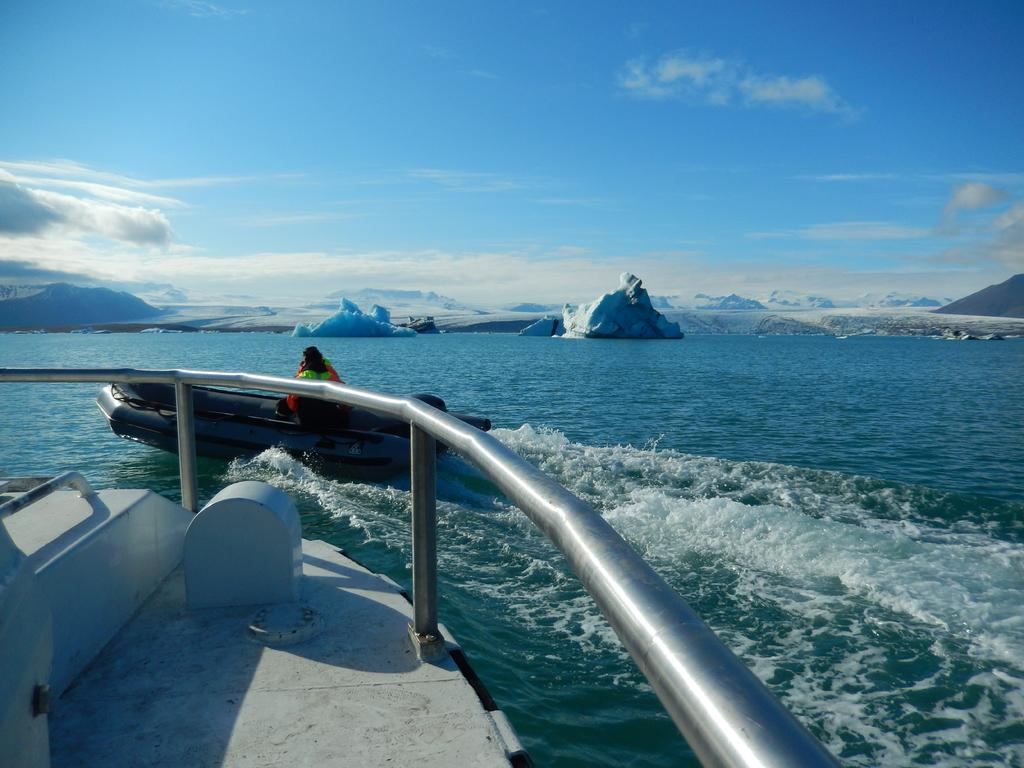What is the main subject in the image? There is a ship on the river in the image. Can you describe the person in the image? There is a person on a boat in front of the ship. What can be seen in the distance in the image? There are mountains in the background of the image. What is visible above the mountains in the image? The sky is visible in the background of the image. What type of plate is being used by the person on the boat in the image? There is no plate visible in the image; the person is on a boat in front of the ship. 